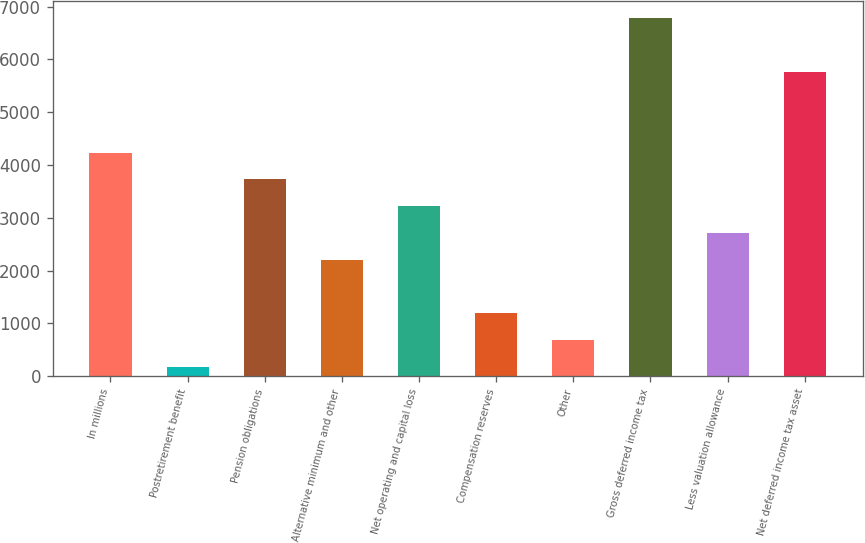Convert chart to OTSL. <chart><loc_0><loc_0><loc_500><loc_500><bar_chart><fcel>In millions<fcel>Postretirement benefit<fcel>Pension obligations<fcel>Alternative minimum and other<fcel>Net operating and capital loss<fcel>Compensation reserves<fcel>Other<fcel>Gross deferred income tax<fcel>Less valuation allowance<fcel>Net deferred income tax asset<nl><fcel>4235.2<fcel>172<fcel>3727.3<fcel>2203.6<fcel>3219.4<fcel>1187.8<fcel>679.9<fcel>6774.7<fcel>2711.5<fcel>5758.9<nl></chart> 